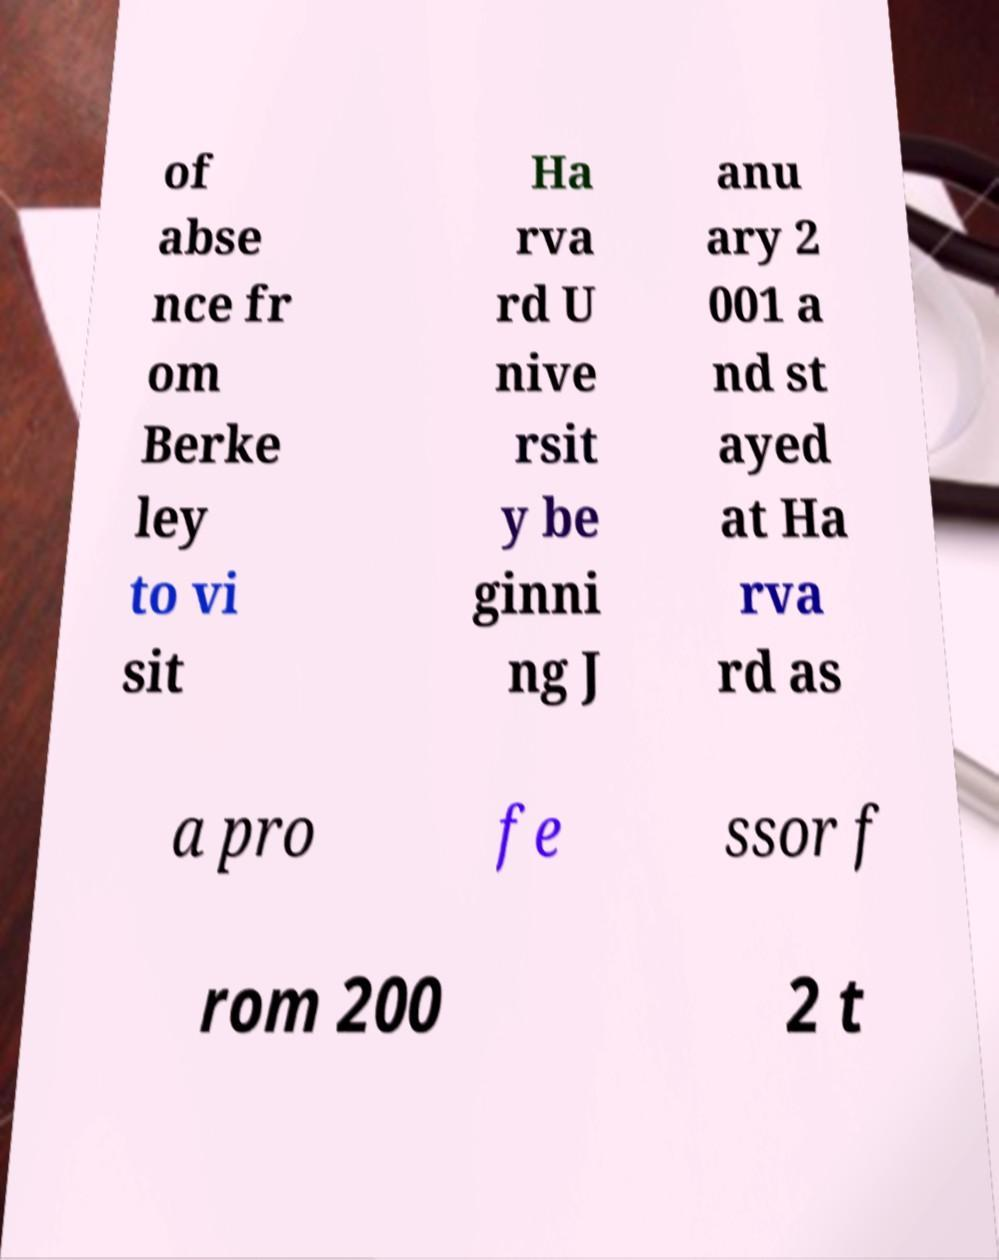For documentation purposes, I need the text within this image transcribed. Could you provide that? of abse nce fr om Berke ley to vi sit Ha rva rd U nive rsit y be ginni ng J anu ary 2 001 a nd st ayed at Ha rva rd as a pro fe ssor f rom 200 2 t 